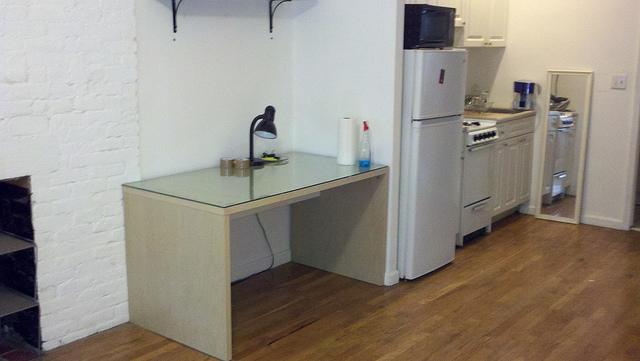What object is out of place in the kitchen? mirror 